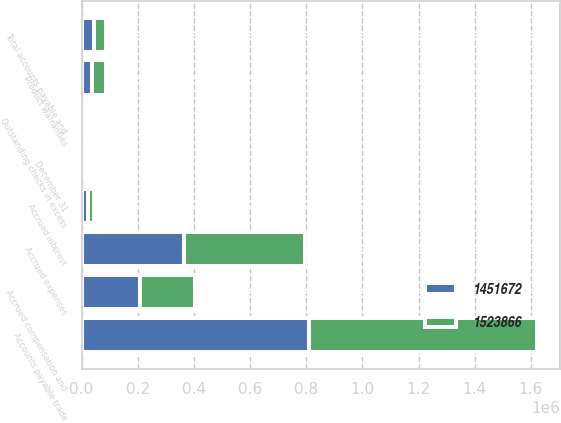<chart> <loc_0><loc_0><loc_500><loc_500><stacked_bar_chart><ecel><fcel>December 31<fcel>Outstanding checks in excess<fcel>Accounts payable trade<fcel>Accrued expenses<fcel>Product warranties<fcel>Accrued interest<fcel>Accrued compensation and<fcel>Total accounts payable and<nl><fcel>1.52387e+06<fcel>2018<fcel>14624<fcel>811879<fcel>430431<fcel>47511<fcel>21908<fcel>197513<fcel>43273<nl><fcel>1.45167e+06<fcel>2017<fcel>8879<fcel>810034<fcel>363919<fcel>39035<fcel>22363<fcel>207442<fcel>43273<nl></chart> 